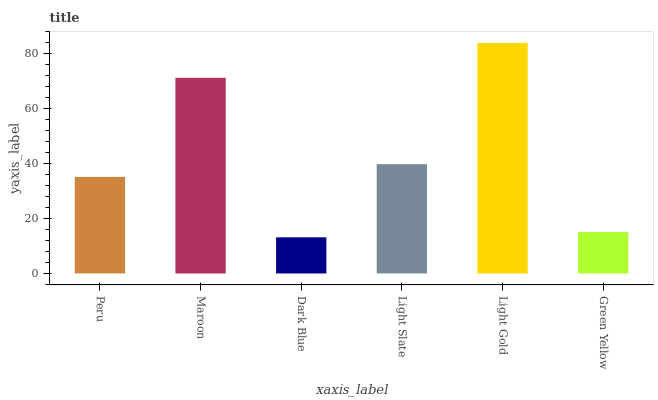Is Dark Blue the minimum?
Answer yes or no. Yes. Is Light Gold the maximum?
Answer yes or no. Yes. Is Maroon the minimum?
Answer yes or no. No. Is Maroon the maximum?
Answer yes or no. No. Is Maroon greater than Peru?
Answer yes or no. Yes. Is Peru less than Maroon?
Answer yes or no. Yes. Is Peru greater than Maroon?
Answer yes or no. No. Is Maroon less than Peru?
Answer yes or no. No. Is Light Slate the high median?
Answer yes or no. Yes. Is Peru the low median?
Answer yes or no. Yes. Is Green Yellow the high median?
Answer yes or no. No. Is Light Slate the low median?
Answer yes or no. No. 